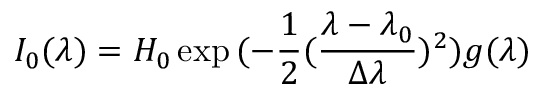Convert formula to latex. <formula><loc_0><loc_0><loc_500><loc_500>I _ { 0 } ( \lambda ) = H _ { 0 } \exp { ( - \frac { 1 } { 2 } ( \frac { \lambda - \lambda _ { 0 } } { \Delta \lambda } ) ^ { 2 } ) } g ( \lambda )</formula> 